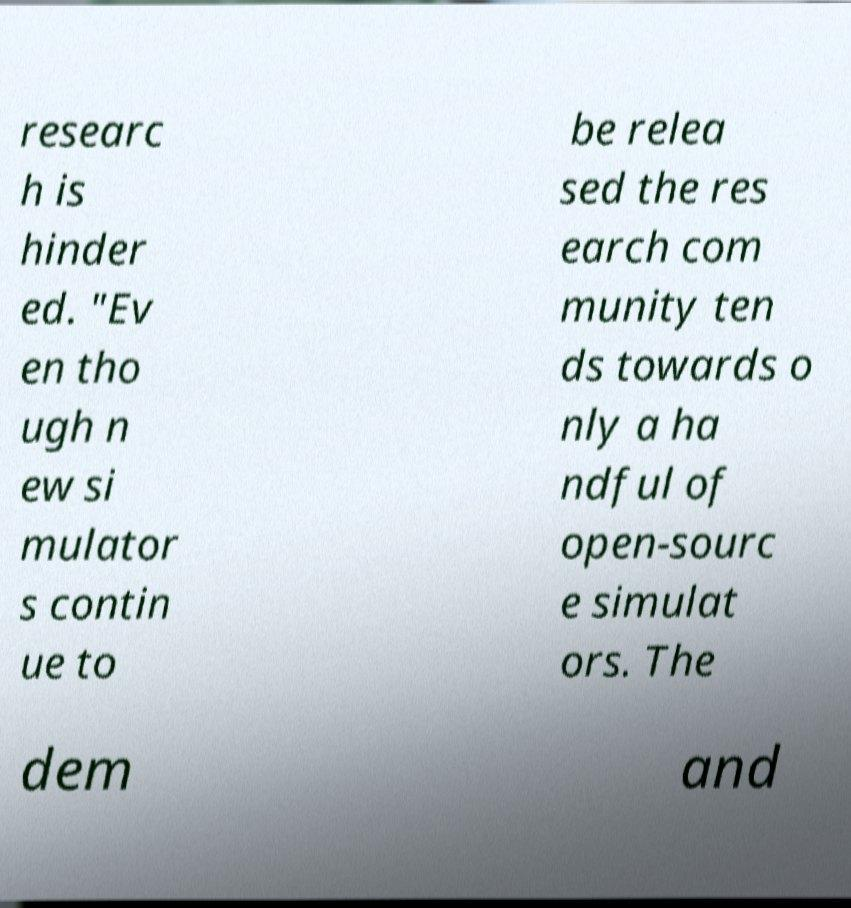Could you extract and type out the text from this image? researc h is hinder ed. "Ev en tho ugh n ew si mulator s contin ue to be relea sed the res earch com munity ten ds towards o nly a ha ndful of open-sourc e simulat ors. The dem and 